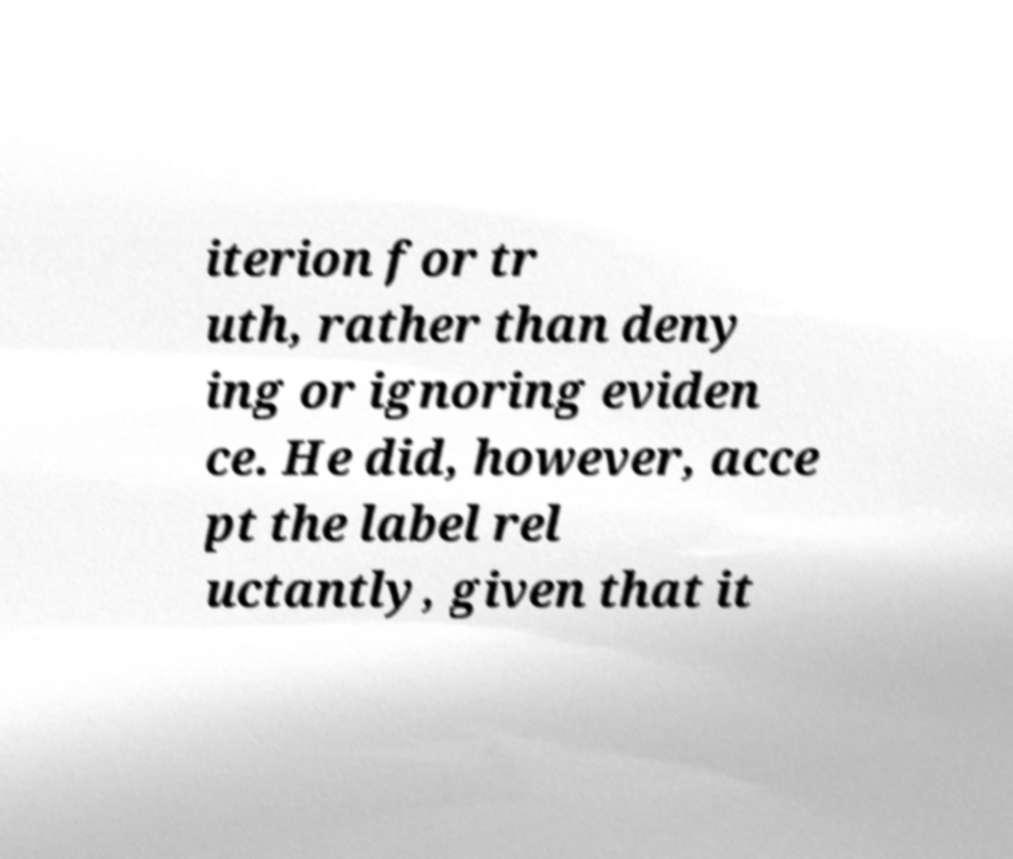Please read and relay the text visible in this image. What does it say? iterion for tr uth, rather than deny ing or ignoring eviden ce. He did, however, acce pt the label rel uctantly, given that it 